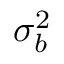Convert formula to latex. <formula><loc_0><loc_0><loc_500><loc_500>\sigma _ { b } ^ { 2 }</formula> 